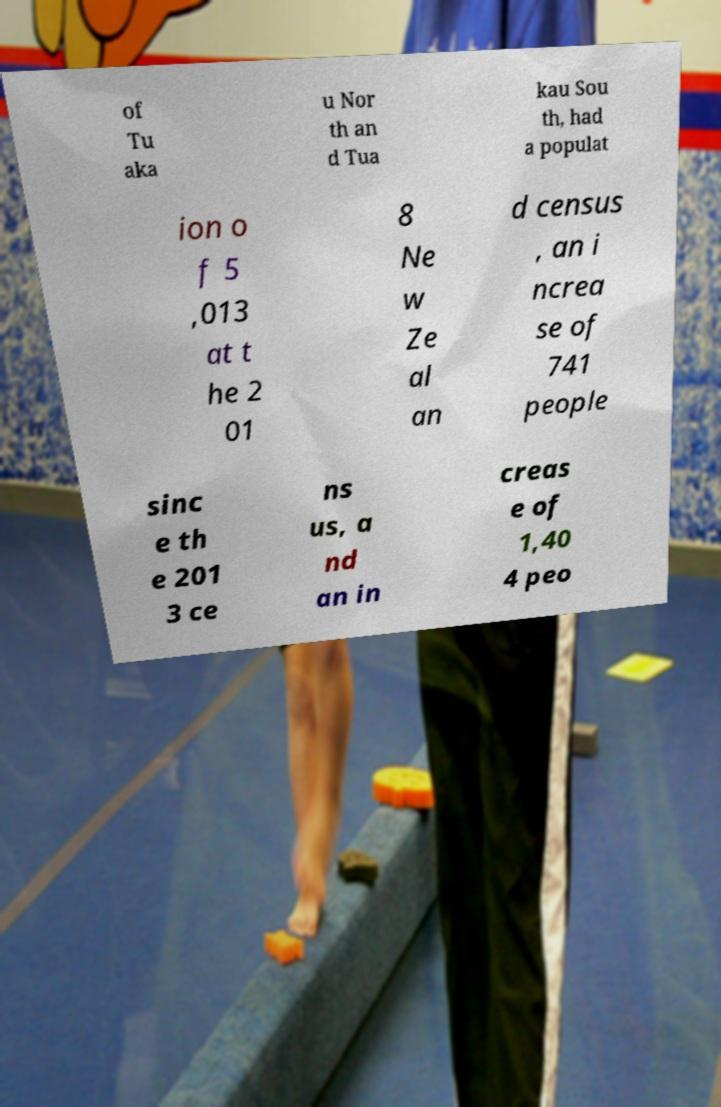Can you accurately transcribe the text from the provided image for me? of Tu aka u Nor th an d Tua kau Sou th, had a populat ion o f 5 ,013 at t he 2 01 8 Ne w Ze al an d census , an i ncrea se of 741 people sinc e th e 201 3 ce ns us, a nd an in creas e of 1,40 4 peo 